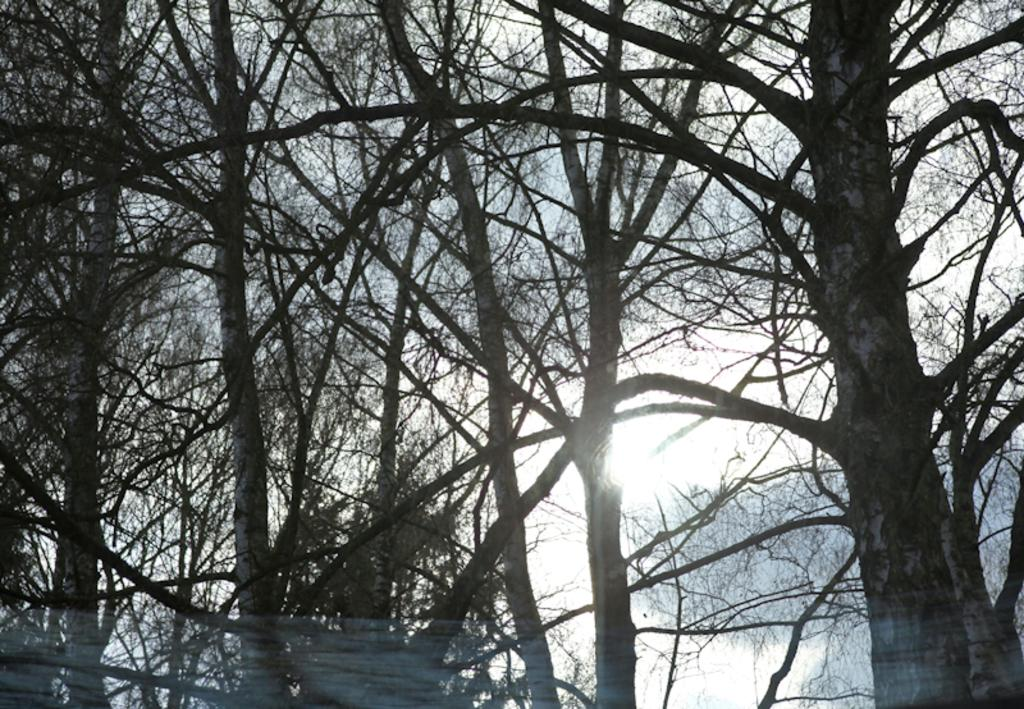What type of vegetation can be seen in the image? There are trees in the image. What time of day is depicted in the image? The sunset is visible in the image, indicating that it is near dusk. What type of shoes can be seen on the dinosaurs in the image? There are no dinosaurs or shoes present in the image. 